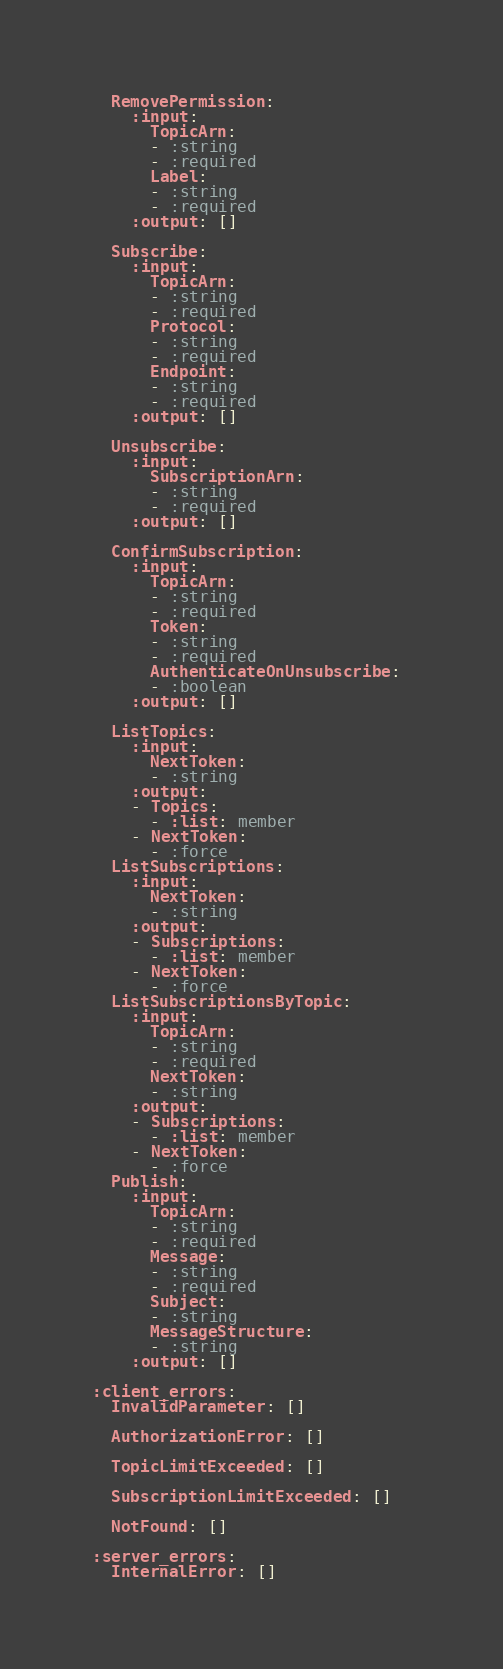Convert code to text. <code><loc_0><loc_0><loc_500><loc_500><_YAML_>
  RemovePermission: 
    :input: 
      TopicArn: 
      - :string
      - :required
      Label: 
      - :string
      - :required
    :output: []

  Subscribe: 
    :input: 
      TopicArn: 
      - :string
      - :required
      Protocol: 
      - :string
      - :required
      Endpoint: 
      - :string
      - :required
    :output: []

  Unsubscribe: 
    :input: 
      SubscriptionArn: 
      - :string
      - :required
    :output: []

  ConfirmSubscription: 
    :input: 
      TopicArn: 
      - :string
      - :required
      Token: 
      - :string
      - :required
      AuthenticateOnUnsubscribe: 
      - :boolean
    :output: []

  ListTopics: 
    :input: 
      NextToken: 
      - :string
    :output: 
    - Topics: 
      - :list: member
    - NextToken: 
      - :force
  ListSubscriptions: 
    :input: 
      NextToken: 
      - :string
    :output: 
    - Subscriptions: 
      - :list: member
    - NextToken: 
      - :force
  ListSubscriptionsByTopic: 
    :input: 
      TopicArn: 
      - :string
      - :required
      NextToken: 
      - :string
    :output: 
    - Subscriptions: 
      - :list: member
    - NextToken: 
      - :force
  Publish: 
    :input: 
      TopicArn: 
      - :string
      - :required
      Message: 
      - :string
      - :required
      Subject: 
      - :string
      MessageStructure: 
      - :string
    :output: []

:client_errors: 
  InvalidParameter: []

  AuthorizationError: []

  TopicLimitExceeded: []

  SubscriptionLimitExceeded: []

  NotFound: []

:server_errors: 
  InternalError: []
</code> 